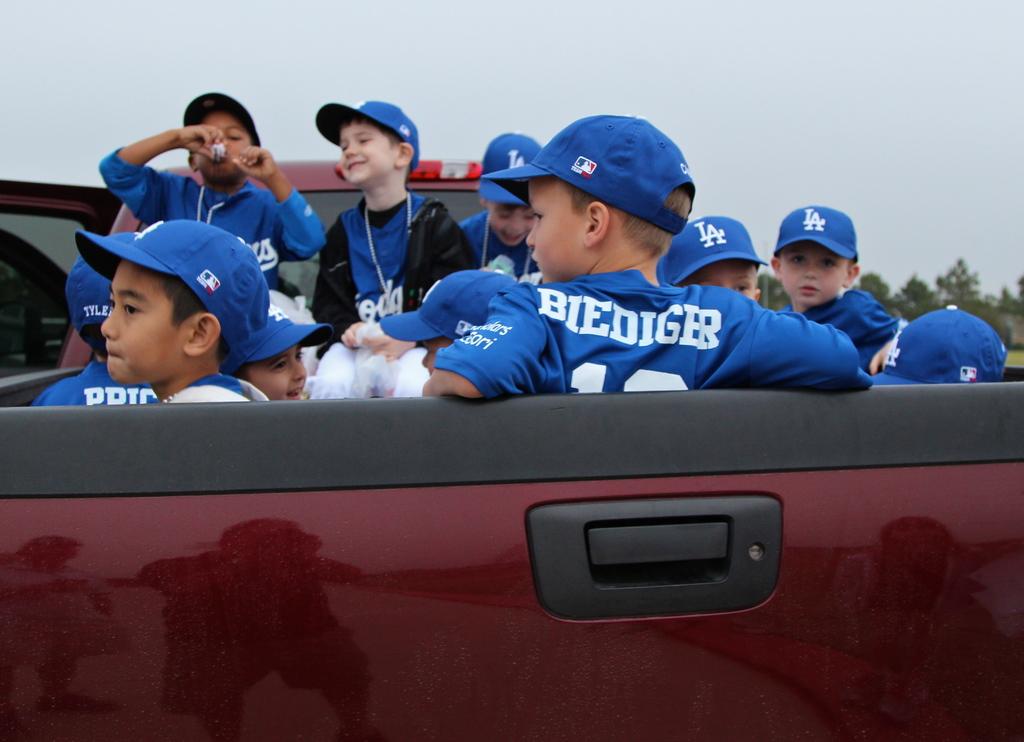What does the back of that players shirt say?
Your response must be concise. Biediger. What letters are on their hats?
Provide a succinct answer. La. 